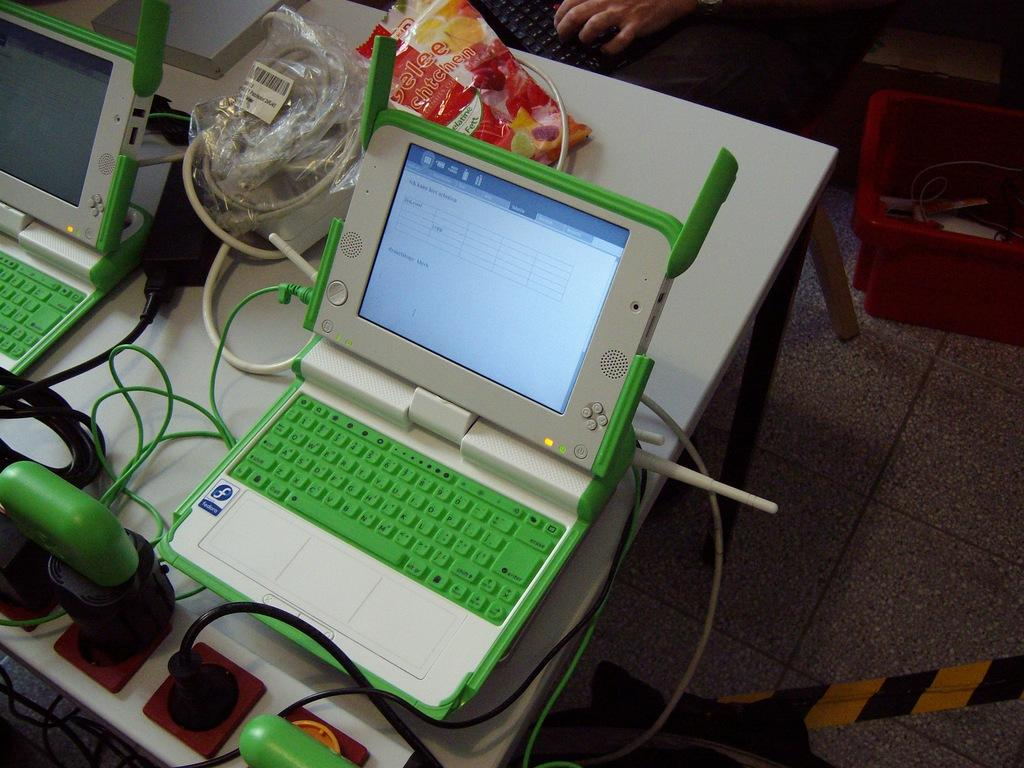What is the main piece of furniture in the image? There is a table in the image. What electronic devices are on the table? There are two laptops on the table. What else can be seen on the table besides the laptops? Wires, a plastic cover, and a switch board are present on the table. Whose hand is visible in the image? A person's hand is visible in the image. What type of grass is growing on the table in the image? There is no grass present on the table in the image. How does the nerve system of the person affect their hand in the image? The image does not provide information about the person's nerve system, so we cannot determine its effect on their hand. 